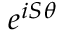Convert formula to latex. <formula><loc_0><loc_0><loc_500><loc_500>e ^ { i S \theta }</formula> 